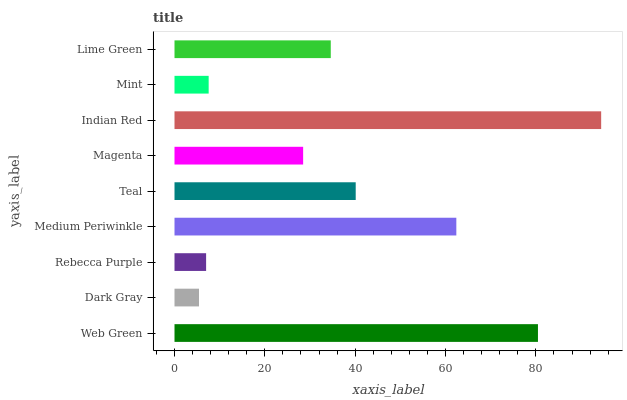Is Dark Gray the minimum?
Answer yes or no. Yes. Is Indian Red the maximum?
Answer yes or no. Yes. Is Rebecca Purple the minimum?
Answer yes or no. No. Is Rebecca Purple the maximum?
Answer yes or no. No. Is Rebecca Purple greater than Dark Gray?
Answer yes or no. Yes. Is Dark Gray less than Rebecca Purple?
Answer yes or no. Yes. Is Dark Gray greater than Rebecca Purple?
Answer yes or no. No. Is Rebecca Purple less than Dark Gray?
Answer yes or no. No. Is Lime Green the high median?
Answer yes or no. Yes. Is Lime Green the low median?
Answer yes or no. Yes. Is Web Green the high median?
Answer yes or no. No. Is Indian Red the low median?
Answer yes or no. No. 